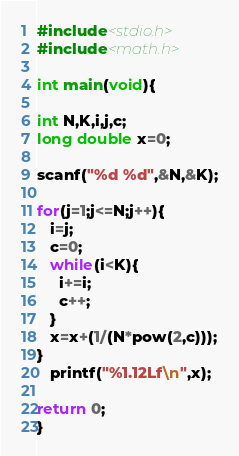Convert code to text. <code><loc_0><loc_0><loc_500><loc_500><_C_>#include<stdio.h>
#include<math.h>

int main(void){

int N,K,i,j,c;
long double x=0;

scanf("%d %d",&N,&K);

for(j=1;j<=N;j++){
   i=j;
   c=0;
   while(i<K){
     i+=i;
     c++;
   }
   x=x+(1/(N*pow(2,c)));
}
   printf("%1.12Lf\n",x);

return 0;
}
</code> 